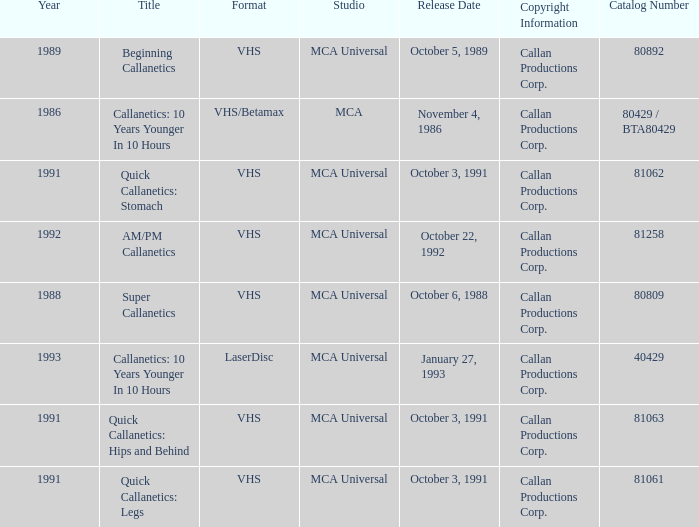Name the catalog number for  october 6, 1988 80809.0. 